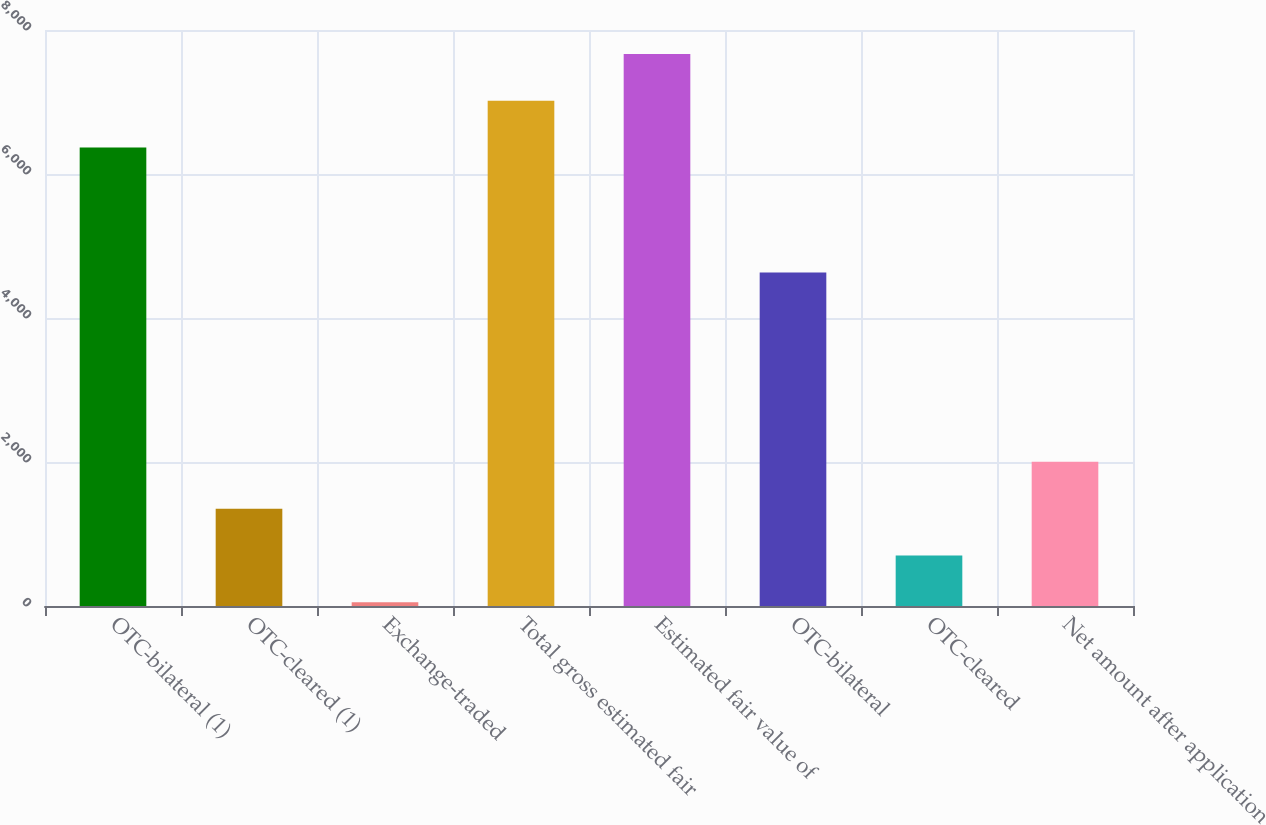<chart> <loc_0><loc_0><loc_500><loc_500><bar_chart><fcel>OTC-bilateral (1)<fcel>OTC-cleared (1)<fcel>Exchange-traded<fcel>Total gross estimated fair<fcel>Estimated fair value of<fcel>OTC-bilateral<fcel>OTC-cleared<fcel>Net amount after application<nl><fcel>6367<fcel>1352.2<fcel>53<fcel>7016.6<fcel>7666.2<fcel>4631<fcel>702.6<fcel>2001.8<nl></chart> 